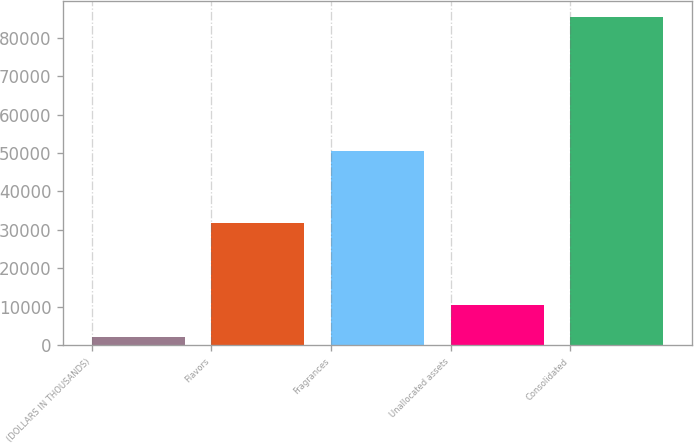Convert chart. <chart><loc_0><loc_0><loc_500><loc_500><bar_chart><fcel>(DOLLARS IN THOUSANDS)<fcel>Flavors<fcel>Fragrances<fcel>Unallocated assets<fcel>Consolidated<nl><fcel>2008<fcel>31858<fcel>50523<fcel>10346.7<fcel>85395<nl></chart> 